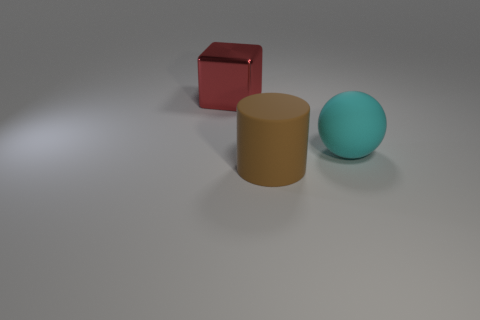Add 1 small shiny spheres. How many objects exist? 4 Subtract all balls. How many objects are left? 2 Add 1 tiny shiny blocks. How many tiny shiny blocks exist? 1 Subtract 0 red cylinders. How many objects are left? 3 Subtract all cyan objects. Subtract all large balls. How many objects are left? 1 Add 3 brown things. How many brown things are left? 4 